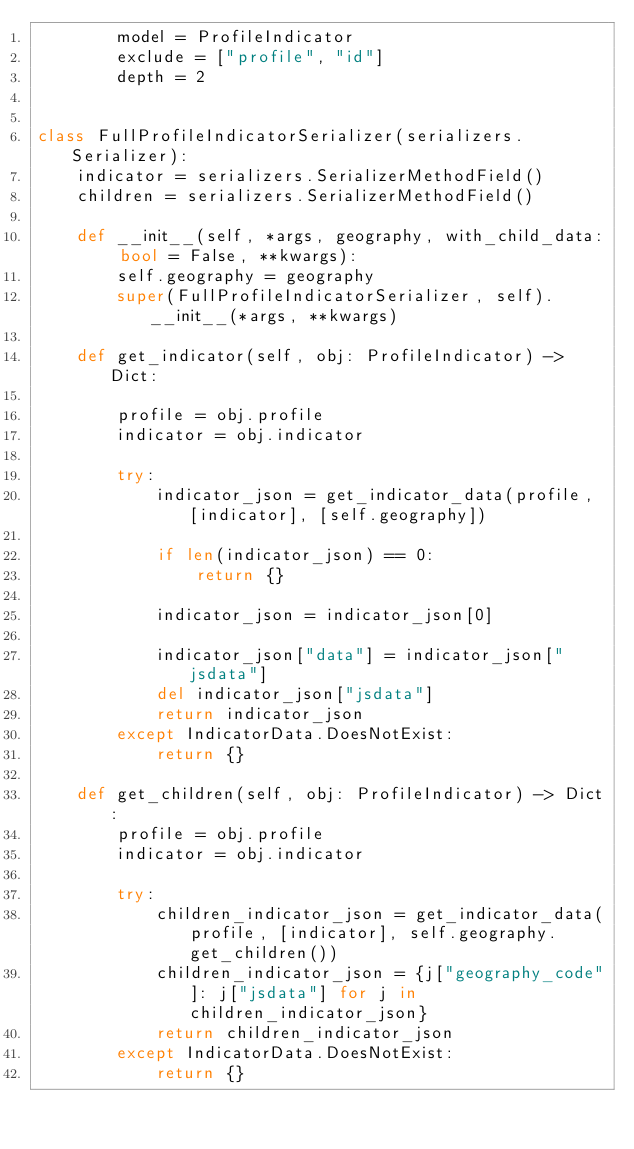<code> <loc_0><loc_0><loc_500><loc_500><_Python_>        model = ProfileIndicator
        exclude = ["profile", "id"]
        depth = 2


class FullProfileIndicatorSerializer(serializers.Serializer):
    indicator = serializers.SerializerMethodField()
    children = serializers.SerializerMethodField()

    def __init__(self, *args, geography, with_child_data: bool = False, **kwargs):
        self.geography = geography
        super(FullProfileIndicatorSerializer, self).__init__(*args, **kwargs)

    def get_indicator(self, obj: ProfileIndicator) -> Dict:

        profile = obj.profile
        indicator = obj.indicator

        try:
            indicator_json = get_indicator_data(profile, [indicator], [self.geography])

            if len(indicator_json) == 0:
                return {}

            indicator_json = indicator_json[0]

            indicator_json["data"] = indicator_json["jsdata"]
            del indicator_json["jsdata"]
            return indicator_json
        except IndicatorData.DoesNotExist:
            return {}

    def get_children(self, obj: ProfileIndicator) -> Dict:
        profile = obj.profile
        indicator = obj.indicator

        try:
            children_indicator_json = get_indicator_data(profile, [indicator], self.geography.get_children())
            children_indicator_json = {j["geography_code"]: j["jsdata"] for j in children_indicator_json}
            return children_indicator_json
        except IndicatorData.DoesNotExist:
            return {}
</code> 